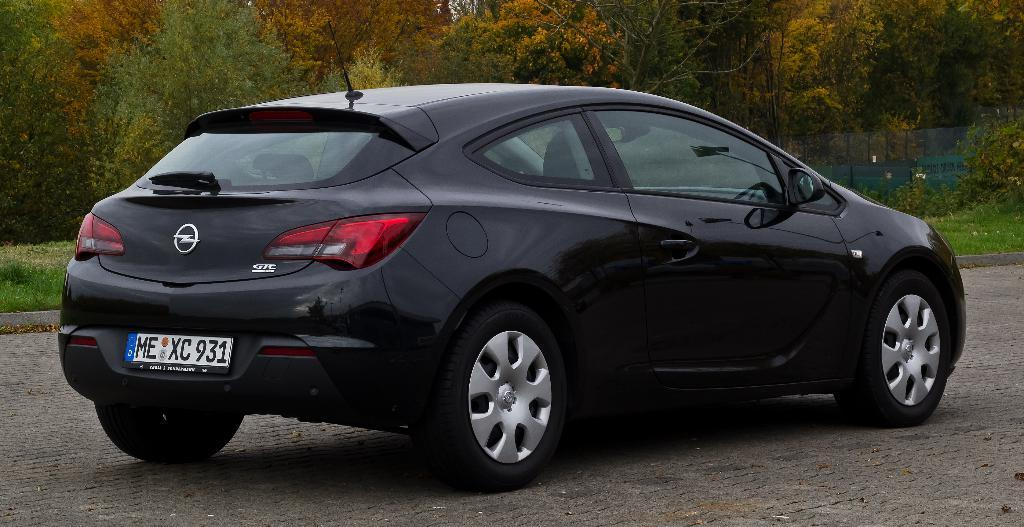What is on the ground in the image? There is a car on the ground in the image. What can be seen in the distance behind the car? There are trees, grass, and a fence in the background of the image. What type of list can be seen hanging on the gate in the image? There is no gate or list present in the image; it only features a car on the ground and elements in the background. 